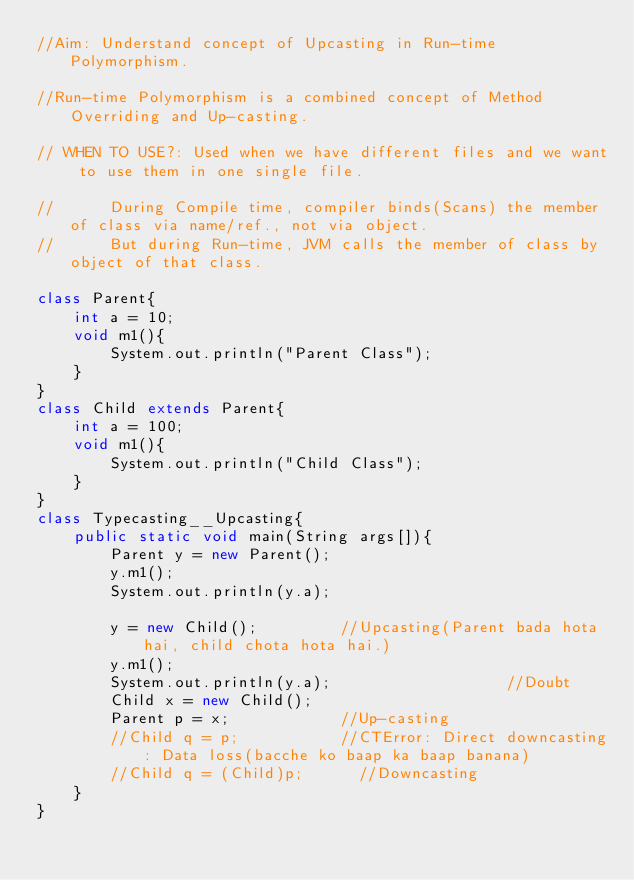Convert code to text. <code><loc_0><loc_0><loc_500><loc_500><_Java_>//Aim: Understand concept of Upcasting in Run-time Polymorphism.

//Run-time Polymorphism is a combined concept of Method Overriding and Up-casting.

// WHEN TO USE?: Used when we have different files and we want to use them in one single file.

// 		During Compile time, compiler binds(Scans) the member of class via name/ref., not via object.
// 		But during Run-time, JVM calls the member of class by object of that class.

class Parent{
	int a = 10;
	void m1(){
		System.out.println("Parent Class");
	}
}
class Child extends Parent{
	int a = 100;              
	void m1(){
		System.out.println("Child Class");     
	}
}
class Typecasting__Upcasting{
	public static void main(String args[]){
		Parent y = new Parent();
		y.m1();
		System.out.println(y.a);
		
		y = new Child();         //Upcasting(Parent bada hota hai, child chota hota hai.)
		y.m1();
		System.out.println(y.a);                   //Doubt
		Child x = new Child();
		Parent p = x;            //Up-casting
		//Child q = p;           //CTError: Direct downcasting: Data loss(bacche ko baap ka baap banana)
		//Child q = (Child)p;      //Downcasting
	}
}</code> 